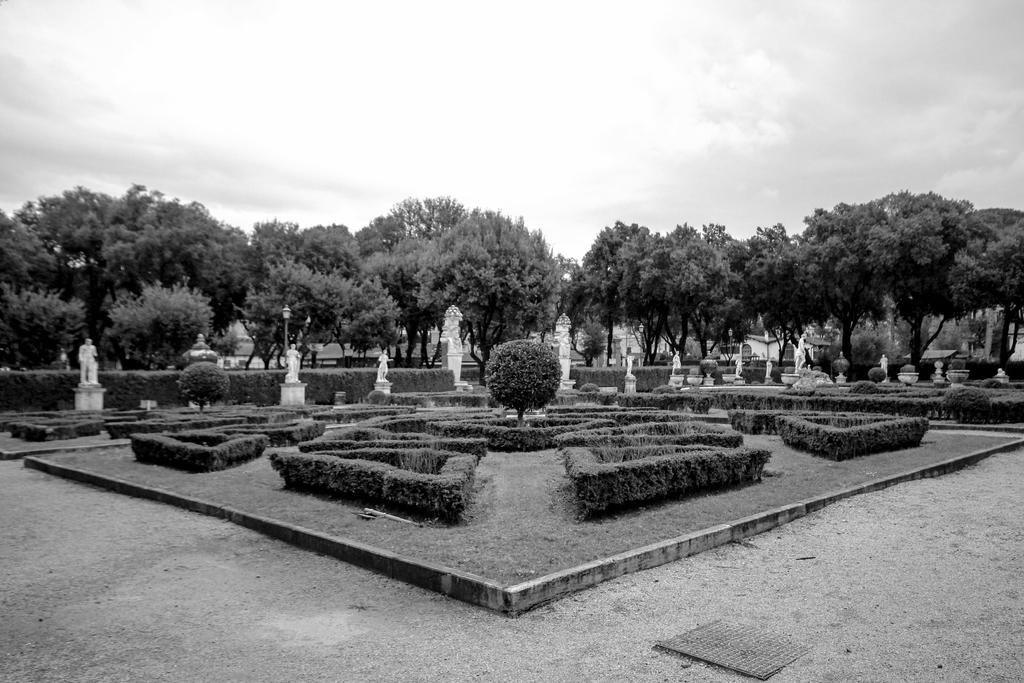What is the color scheme of the image? The image is black and white. What type of vegetation can be seen in the image? There are trees and bushes in the image. What type of artwork is present in the image? There are sculptures in the image. What is visible at the top of the image? The sky is visible at the top of the image. What type of coat is the tree wearing in the image? There are no coats present in the image, as trees do not wear clothing. 